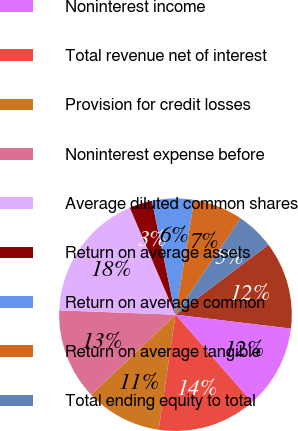Convert chart. <chart><loc_0><loc_0><loc_500><loc_500><pie_chart><fcel>Net interest income<fcel>Noninterest income<fcel>Total revenue net of interest<fcel>Provision for credit losses<fcel>Noninterest expense before<fcel>Average diluted common shares<fcel>Return on average assets<fcel>Return on average common<fcel>Return on average tangible<fcel>Total ending equity to total<nl><fcel>12.17%<fcel>11.64%<fcel>13.76%<fcel>10.58%<fcel>12.7%<fcel>17.99%<fcel>3.17%<fcel>5.82%<fcel>6.88%<fcel>5.29%<nl></chart> 